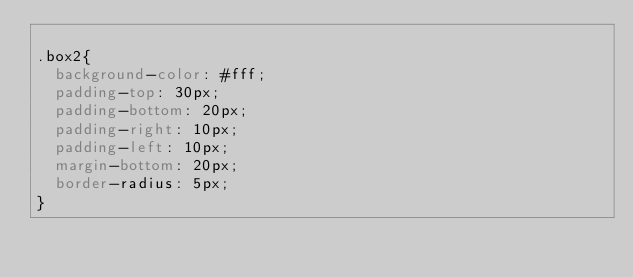<code> <loc_0><loc_0><loc_500><loc_500><_CSS_>
.box2{
  background-color: #fff; 
  padding-top: 30px; 
  padding-bottom: 20px;
  padding-right: 10px; 
  padding-left: 10px; 
  margin-bottom: 20px; 
  border-radius: 5px;
}</code> 